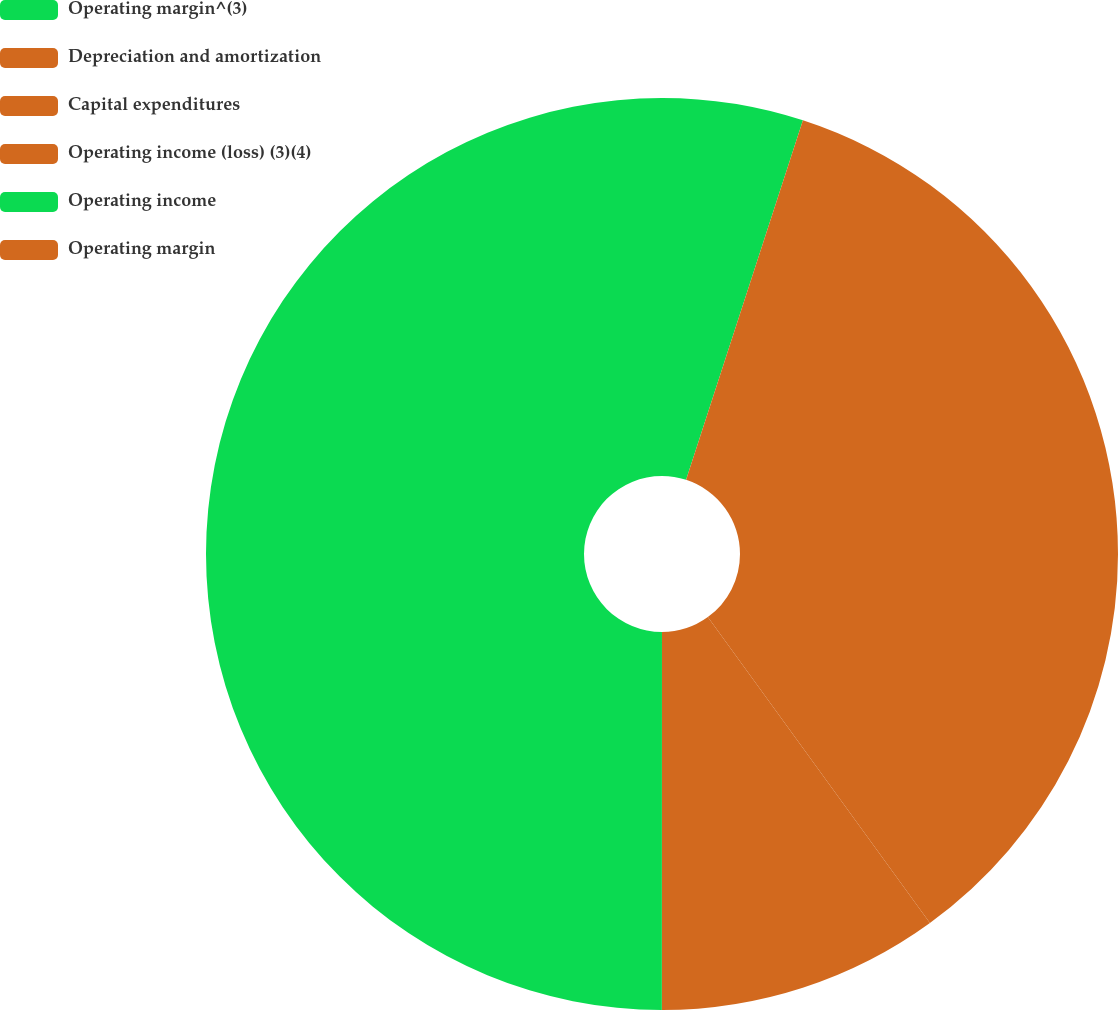Convert chart to OTSL. <chart><loc_0><loc_0><loc_500><loc_500><pie_chart><fcel>Operating margin^(3)<fcel>Depreciation and amortization<fcel>Capital expenditures<fcel>Operating income (loss) (3)(4)<fcel>Operating income<fcel>Operating margin<nl><fcel>5.0%<fcel>20.0%<fcel>15.0%<fcel>10.0%<fcel>49.99%<fcel>0.0%<nl></chart> 